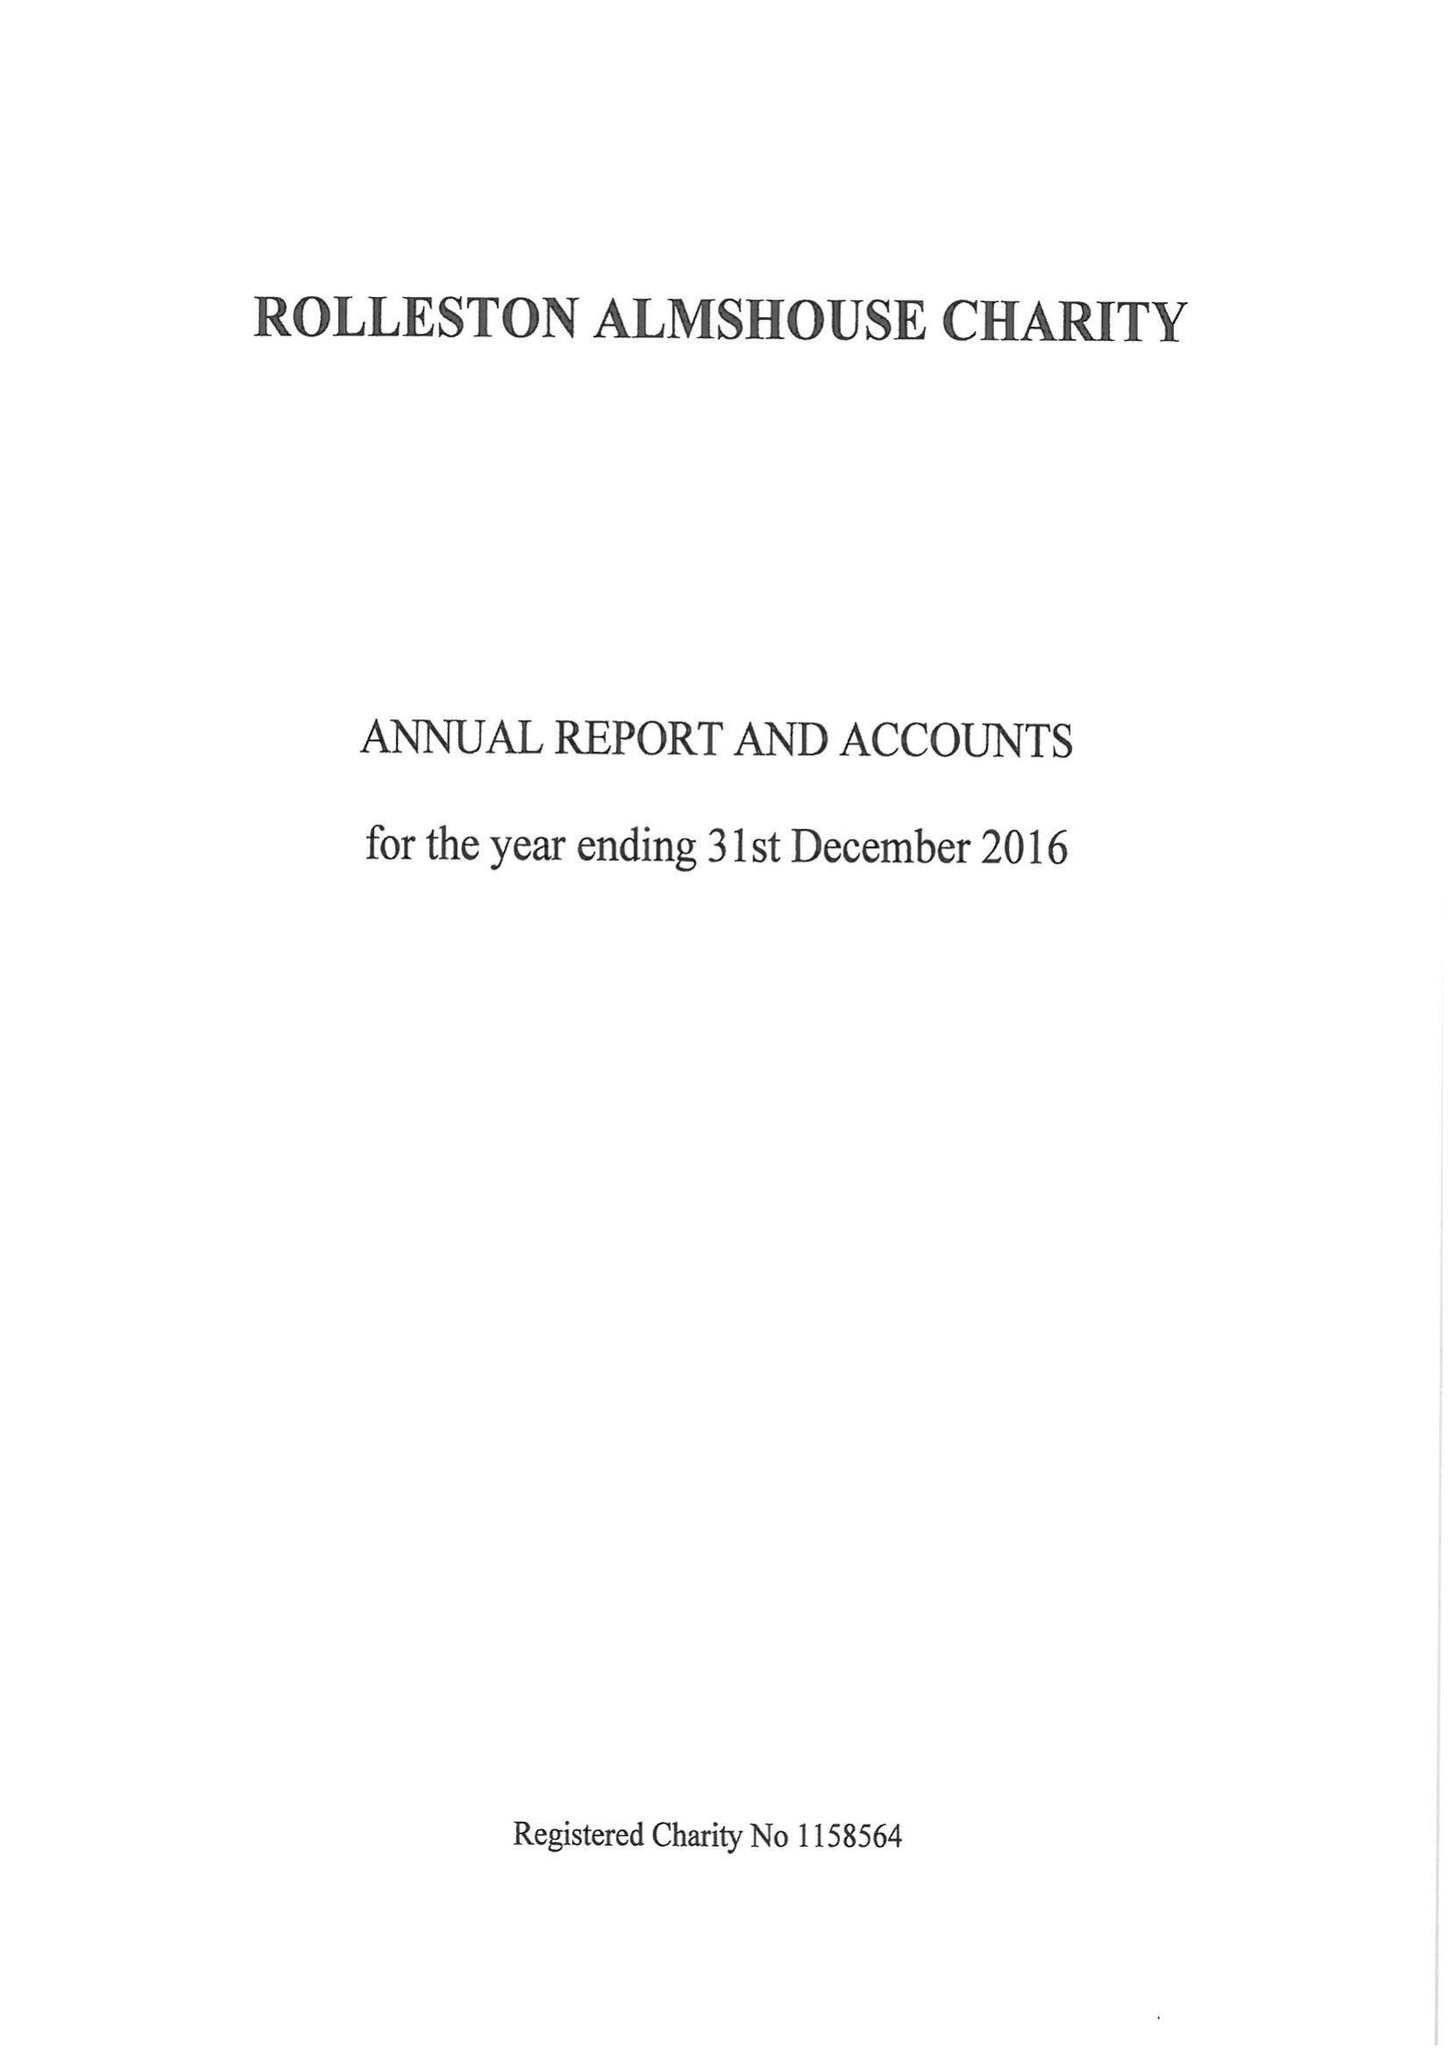What is the value for the address__postcode?
Answer the question using a single word or phrase. DE14 1JY 